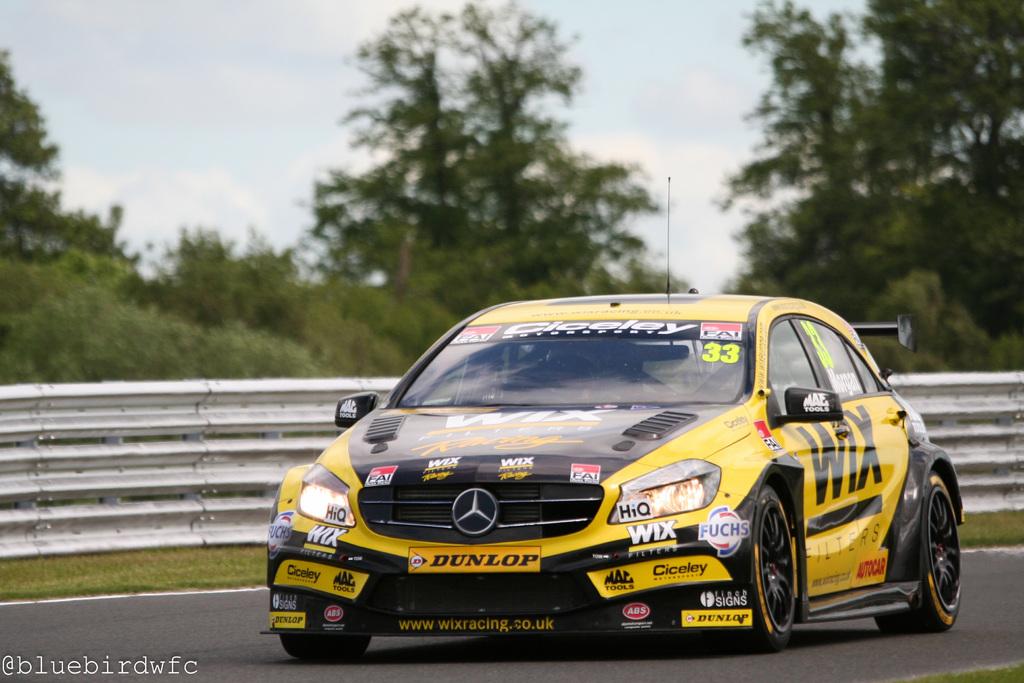What does the side of the car say?
Give a very brief answer. Wix. What is the website on the bottom front of the car?
Offer a very short reply. Www.wixracing.co.uk. 